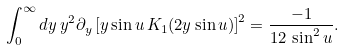Convert formula to latex. <formula><loc_0><loc_0><loc_500><loc_500>\int _ { 0 } ^ { \infty } d y \, y ^ { 2 } { \partial } _ { y } \left [ y \sin u \, K _ { 1 } ( 2 y \sin u ) \right ] ^ { 2 } = \frac { - 1 } { 1 2 \, \sin ^ { 2 } u } .</formula> 